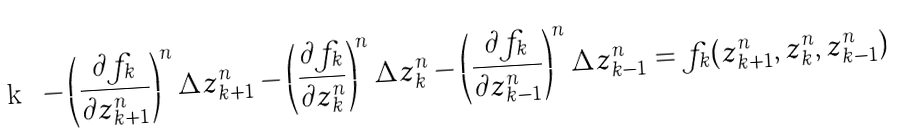Convert formula to latex. <formula><loc_0><loc_0><loc_500><loc_500>- \left ( \frac { \partial f _ { k } } { \partial z _ { k + 1 } ^ { n } } \right ) ^ { n } \Delta z _ { k + 1 } ^ { n } - \left ( \frac { \partial f _ { k } } { \partial z _ { k } ^ { n } } \right ) ^ { n } \Delta z _ { k } ^ { n } - \left ( \frac { \partial f _ { k } } { \partial z _ { k - 1 } ^ { n } } \right ) ^ { n } \Delta z _ { k - 1 } ^ { n } = f _ { k } ( z _ { k + 1 } ^ { n } , z _ { k } ^ { n } , z _ { k - 1 } ^ { n } )</formula> 